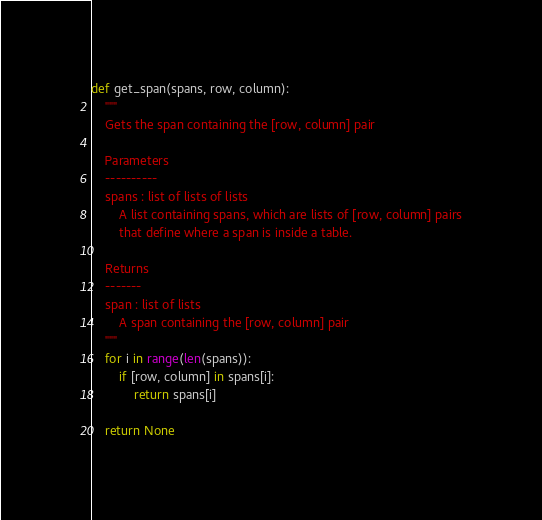<code> <loc_0><loc_0><loc_500><loc_500><_Python_>def get_span(spans, row, column):
    """
    Gets the span containing the [row, column] pair

    Parameters
    ----------
    spans : list of lists of lists
        A list containing spans, which are lists of [row, column] pairs
        that define where a span is inside a table.

    Returns
    -------
    span : list of lists
        A span containing the [row, column] pair
    """
    for i in range(len(spans)):
        if [row, column] in spans[i]:
            return spans[i]

    return None

</code> 